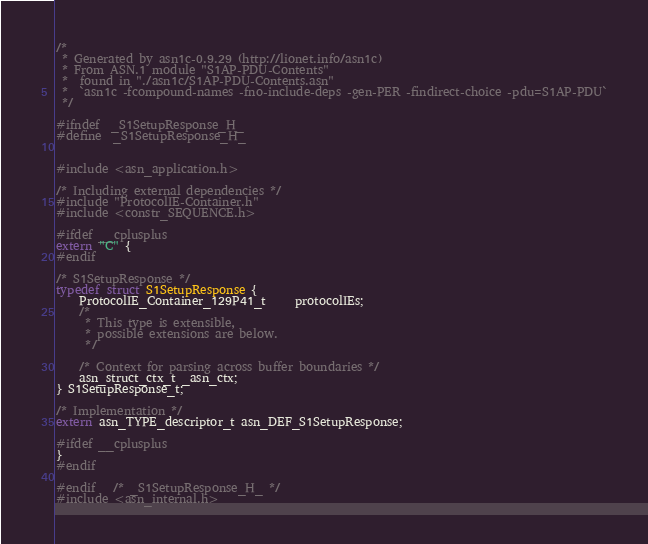Convert code to text. <code><loc_0><loc_0><loc_500><loc_500><_C_>/*
 * Generated by asn1c-0.9.29 (http://lionet.info/asn1c)
 * From ASN.1 module "S1AP-PDU-Contents"
 * 	found in "./asn1c/S1AP-PDU-Contents.asn"
 * 	`asn1c -fcompound-names -fno-include-deps -gen-PER -findirect-choice -pdu=S1AP-PDU`
 */

#ifndef	_S1SetupResponse_H_
#define	_S1SetupResponse_H_


#include <asn_application.h>

/* Including external dependencies */
#include "ProtocolIE-Container.h"
#include <constr_SEQUENCE.h>

#ifdef __cplusplus
extern "C" {
#endif

/* S1SetupResponse */
typedef struct S1SetupResponse {
	ProtocolIE_Container_129P41_t	 protocolIEs;
	/*
	 * This type is extensible,
	 * possible extensions are below.
	 */
	
	/* Context for parsing across buffer boundaries */
	asn_struct_ctx_t _asn_ctx;
} S1SetupResponse_t;

/* Implementation */
extern asn_TYPE_descriptor_t asn_DEF_S1SetupResponse;

#ifdef __cplusplus
}
#endif

#endif	/* _S1SetupResponse_H_ */
#include <asn_internal.h>
</code> 